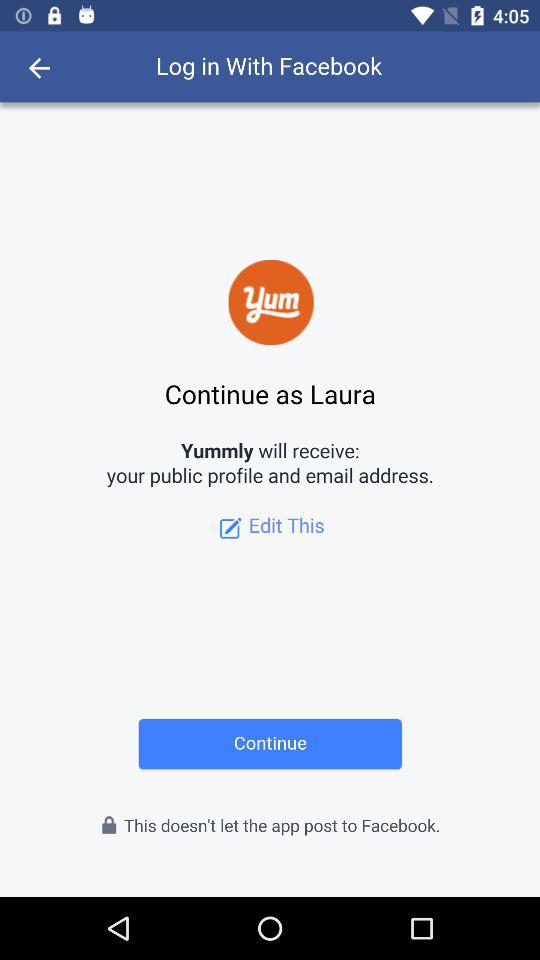What is the user name? The user name is Laura. 